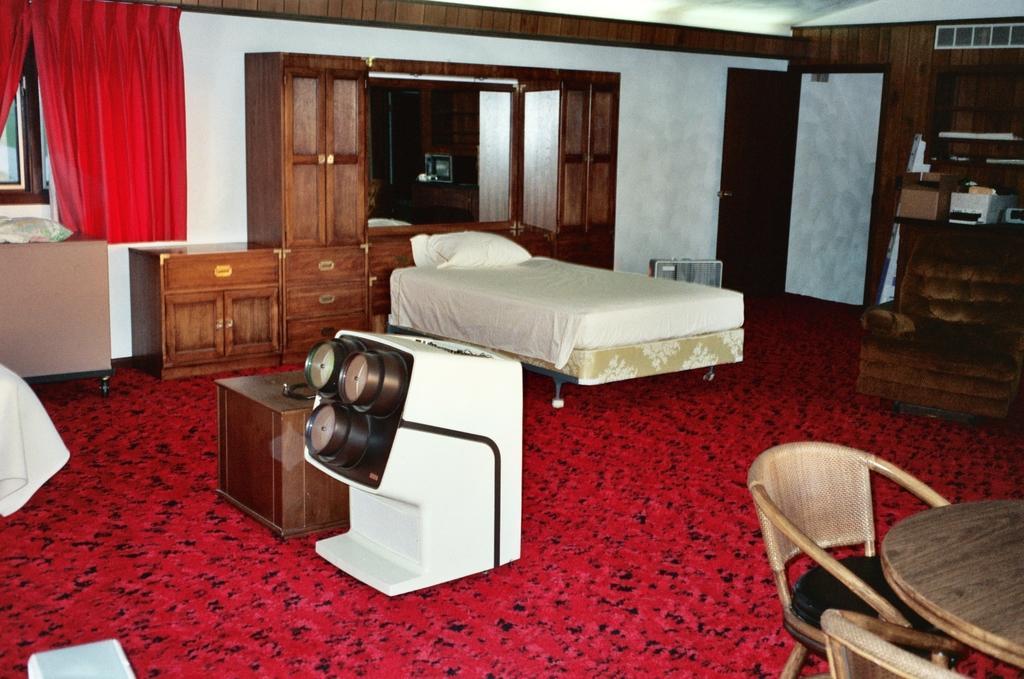How would you summarize this image in a sentence or two? The image is inside the room. In the image there is a bed, on bed we can see a pillow. On right side we can see a door which is opened,couch and a table,mirror in middle there is a table and two chairs. On left side we can see table, on table we can see a pillow and window,curtains at bottom there is a mat which is in red color. 